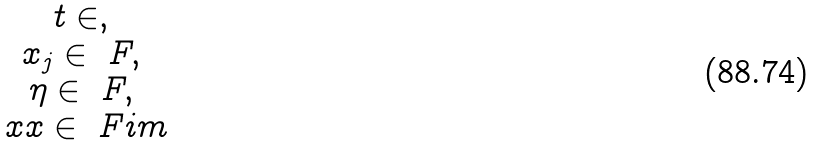Convert formula to latex. <formula><loc_0><loc_0><loc_500><loc_500>\begin{matrix} t \in \real , \\ x _ { j } \in \ F , \\ \eta \in \ F , \\ \ x x \in \ F i m \end{matrix}</formula> 